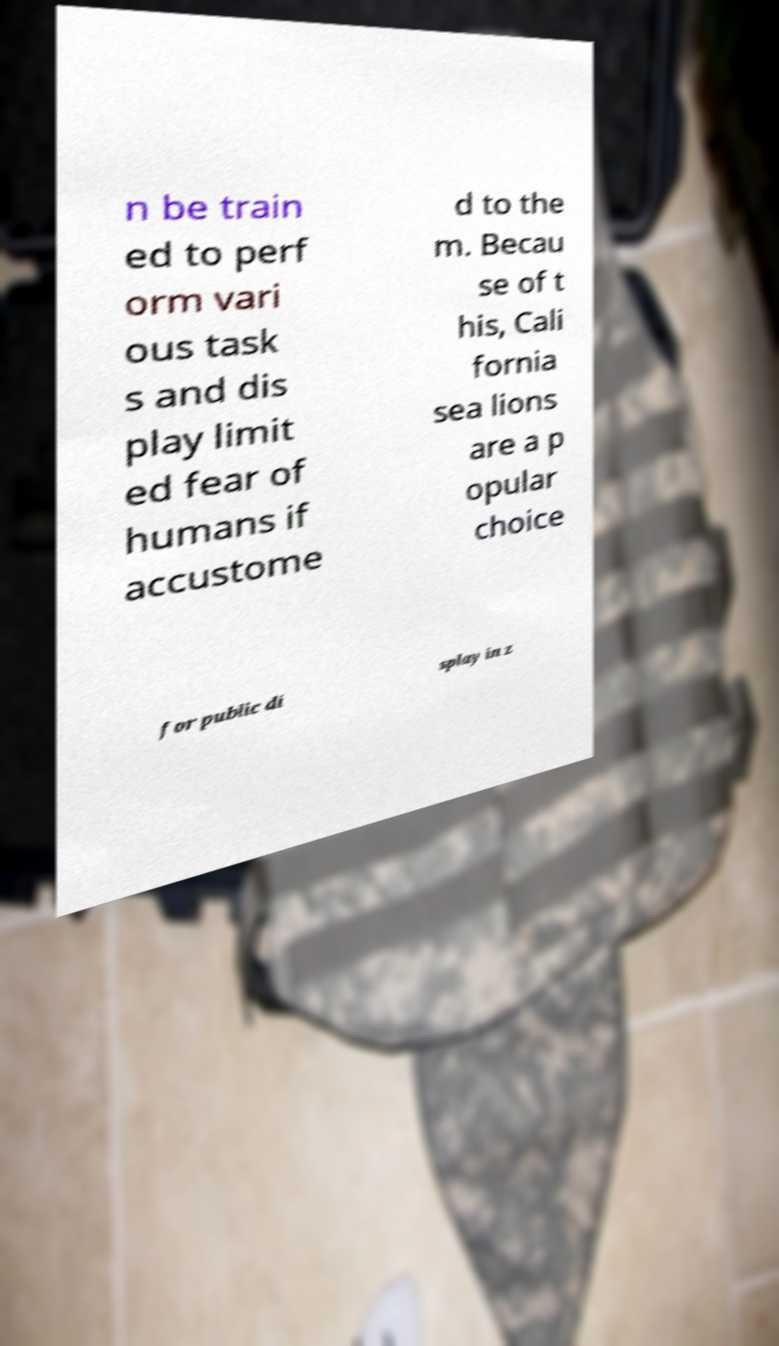Can you read and provide the text displayed in the image?This photo seems to have some interesting text. Can you extract and type it out for me? n be train ed to perf orm vari ous task s and dis play limit ed fear of humans if accustome d to the m. Becau se of t his, Cali fornia sea lions are a p opular choice for public di splay in z 